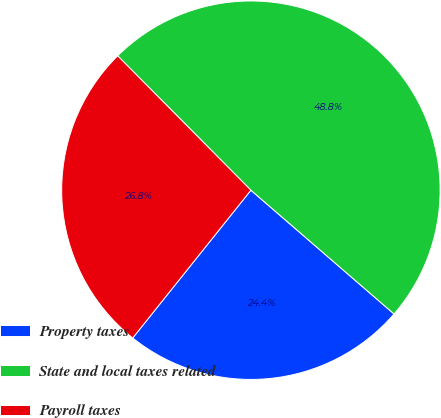Convert chart to OTSL. <chart><loc_0><loc_0><loc_500><loc_500><pie_chart><fcel>Property taxes<fcel>State and local taxes related<fcel>Payroll taxes<nl><fcel>24.39%<fcel>48.78%<fcel>26.83%<nl></chart> 